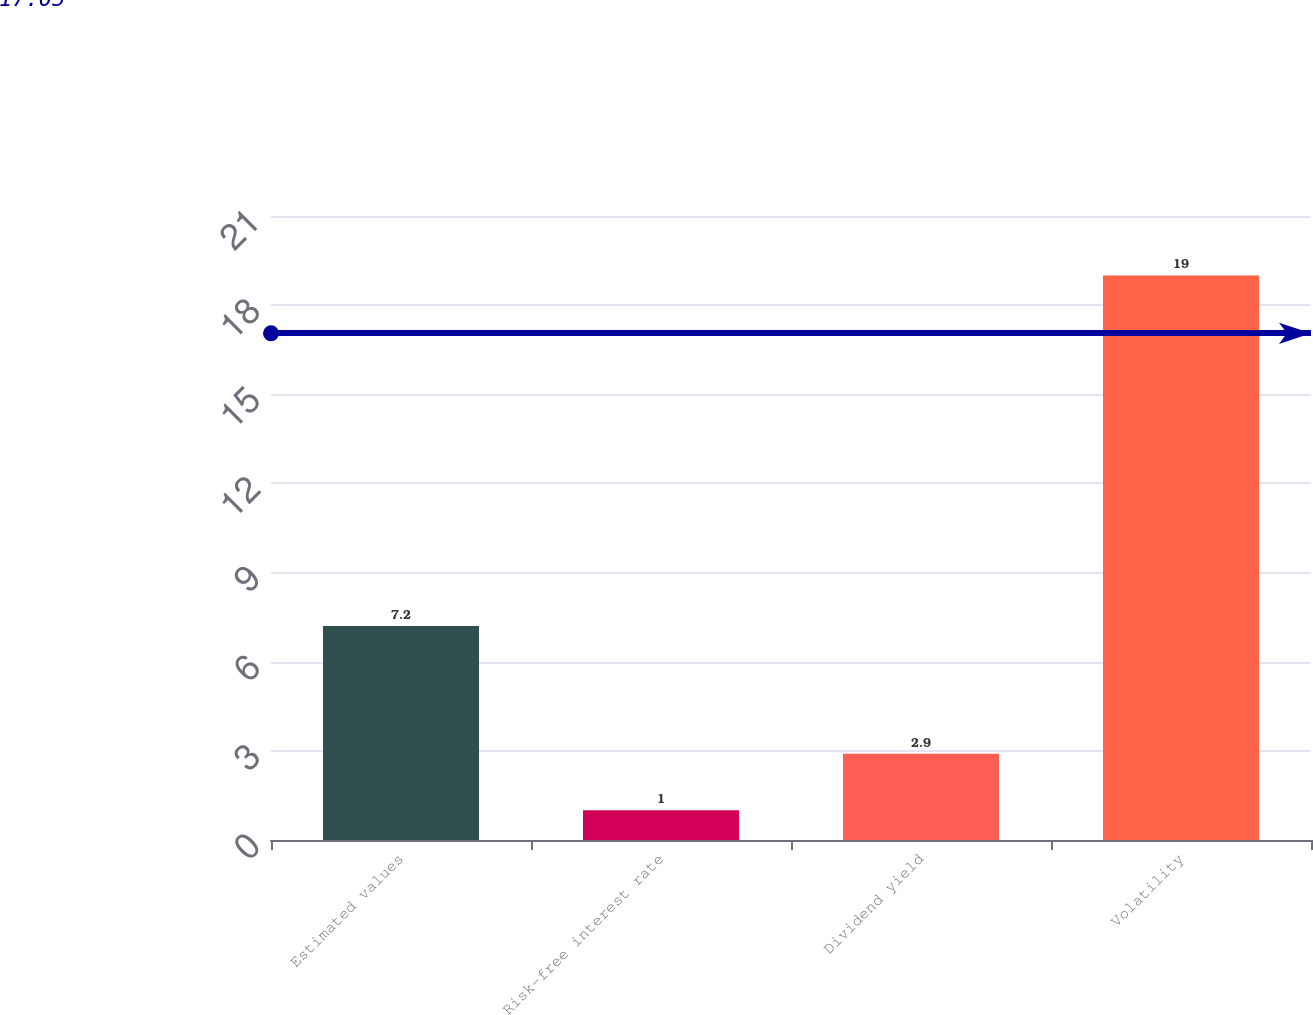Convert chart. <chart><loc_0><loc_0><loc_500><loc_500><bar_chart><fcel>Estimated values<fcel>Risk-free interest rate<fcel>Dividend yield<fcel>Volatility<nl><fcel>7.2<fcel>1<fcel>2.9<fcel>19<nl></chart> 